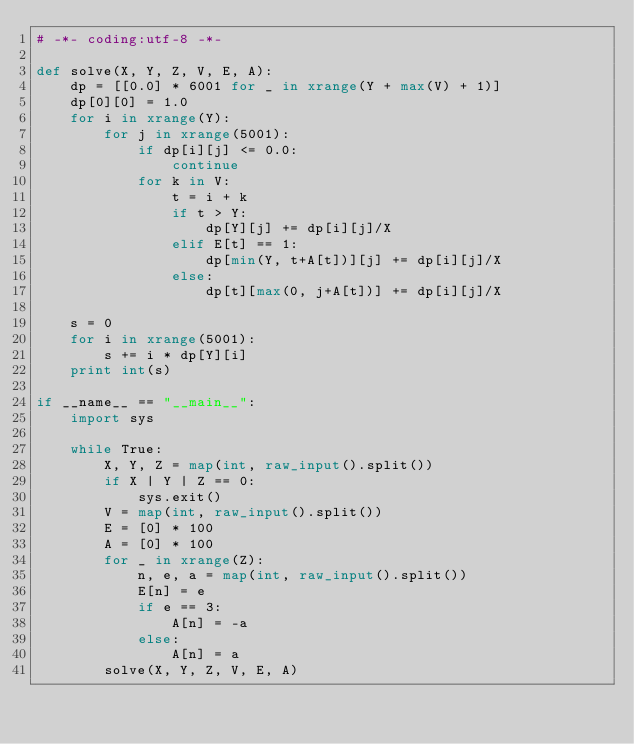Convert code to text. <code><loc_0><loc_0><loc_500><loc_500><_Python_># -*- coding:utf-8 -*-

def solve(X, Y, Z, V, E, A):
    dp = [[0.0] * 6001 for _ in xrange(Y + max(V) + 1)]
    dp[0][0] = 1.0
    for i in xrange(Y):
        for j in xrange(5001):
            if dp[i][j] <= 0.0:
                continue
            for k in V:
                t = i + k
                if t > Y:
                    dp[Y][j] += dp[i][j]/X
                elif E[t] == 1:
                    dp[min(Y, t+A[t])][j] += dp[i][j]/X
                else:
                    dp[t][max(0, j+A[t])] += dp[i][j]/X

    s = 0
    for i in xrange(5001):
        s += i * dp[Y][i]
    print int(s)

if __name__ == "__main__":
    import sys

    while True:
        X, Y, Z = map(int, raw_input().split())
        if X | Y | Z == 0:
            sys.exit()
        V = map(int, raw_input().split())
        E = [0] * 100
        A = [0] * 100
        for _ in xrange(Z):
            n, e, a = map(int, raw_input().split())
            E[n] = e
            if e == 3:
                A[n] = -a
            else:
                A[n] = a
        solve(X, Y, Z, V, E, A)</code> 